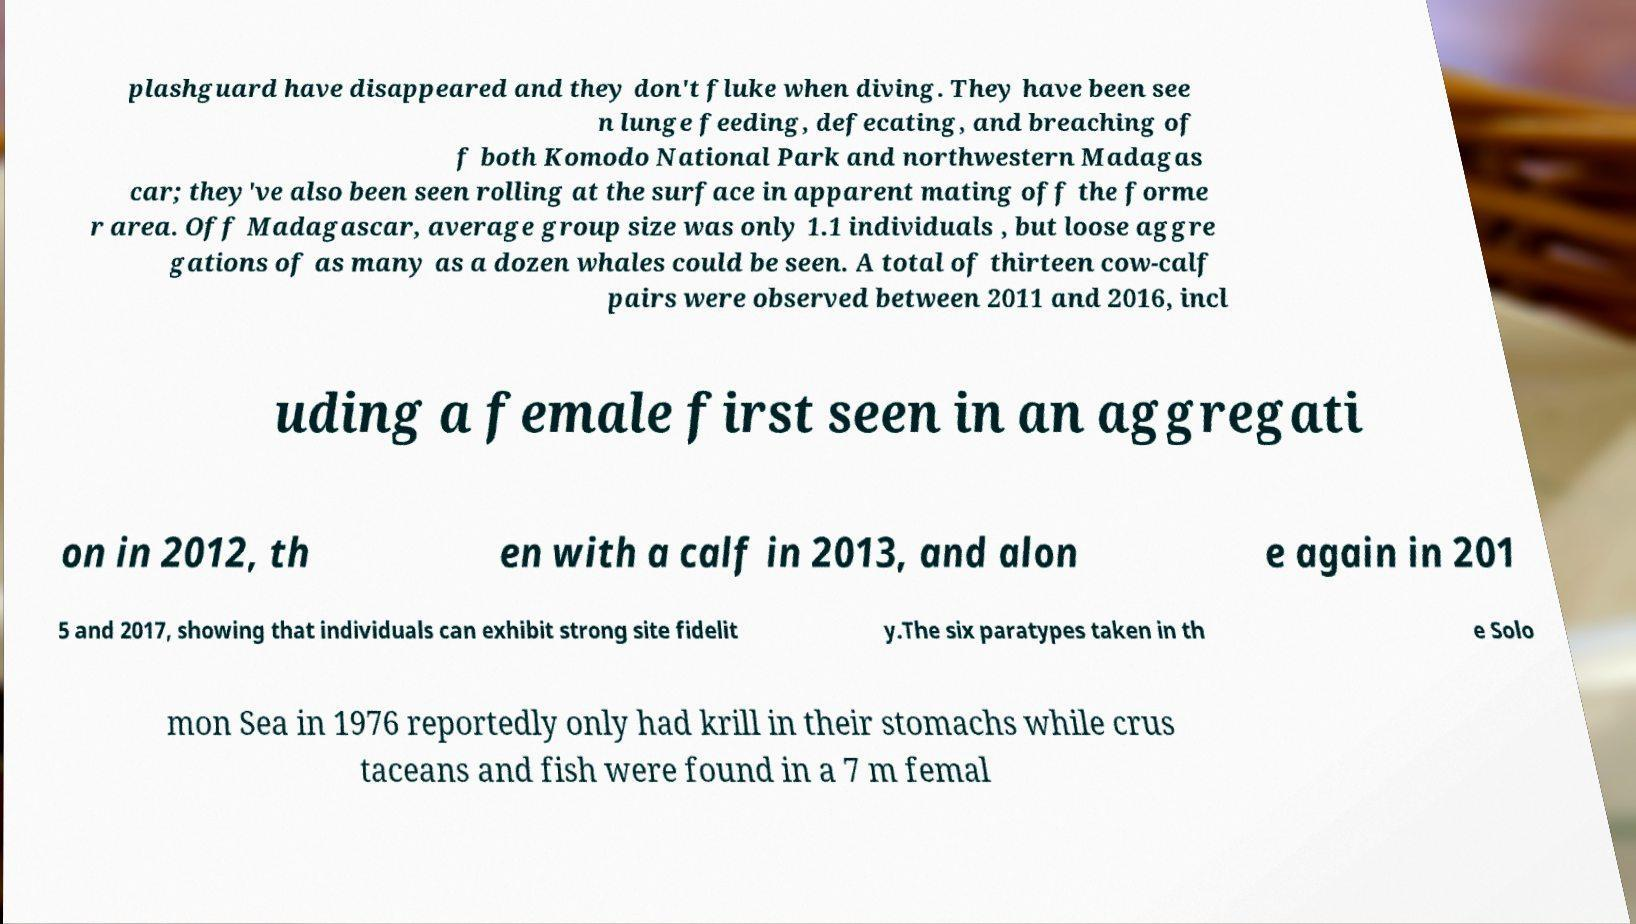Can you read and provide the text displayed in the image?This photo seems to have some interesting text. Can you extract and type it out for me? plashguard have disappeared and they don't fluke when diving. They have been see n lunge feeding, defecating, and breaching of f both Komodo National Park and northwestern Madagas car; they've also been seen rolling at the surface in apparent mating off the forme r area. Off Madagascar, average group size was only 1.1 individuals , but loose aggre gations of as many as a dozen whales could be seen. A total of thirteen cow-calf pairs were observed between 2011 and 2016, incl uding a female first seen in an aggregati on in 2012, th en with a calf in 2013, and alon e again in 201 5 and 2017, showing that individuals can exhibit strong site fidelit y.The six paratypes taken in th e Solo mon Sea in 1976 reportedly only had krill in their stomachs while crus taceans and fish were found in a 7 m femal 